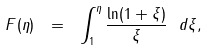Convert formula to latex. <formula><loc_0><loc_0><loc_500><loc_500>F ( \eta ) \ = \ \int _ { 1 } ^ { \eta } \frac { \ln ( 1 + \xi ) } \xi \ d \xi ,</formula> 